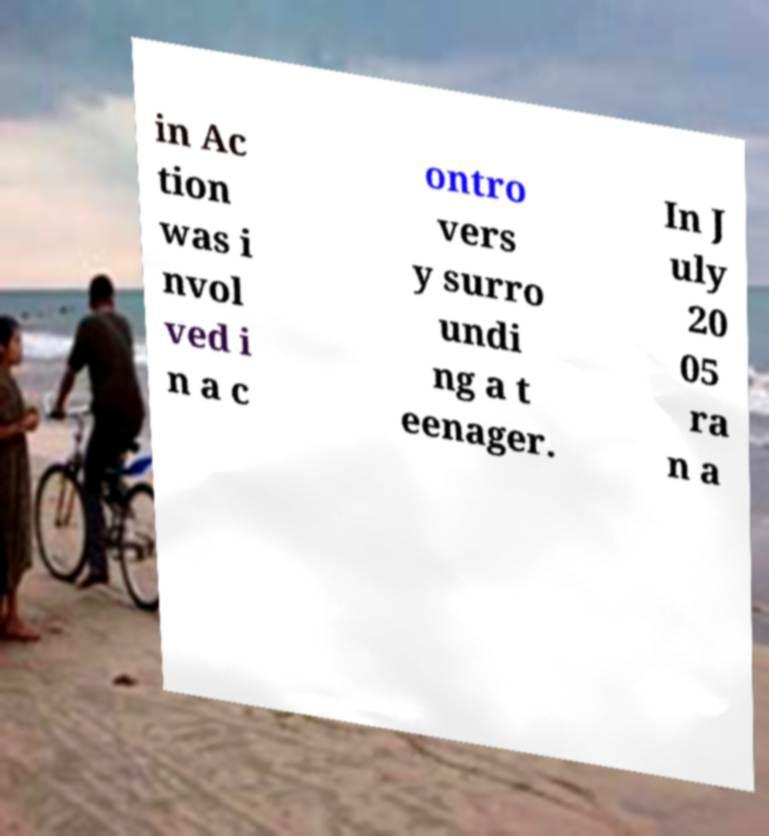What messages or text are displayed in this image? I need them in a readable, typed format. in Ac tion was i nvol ved i n a c ontro vers y surro undi ng a t eenager. In J uly 20 05 ra n a 